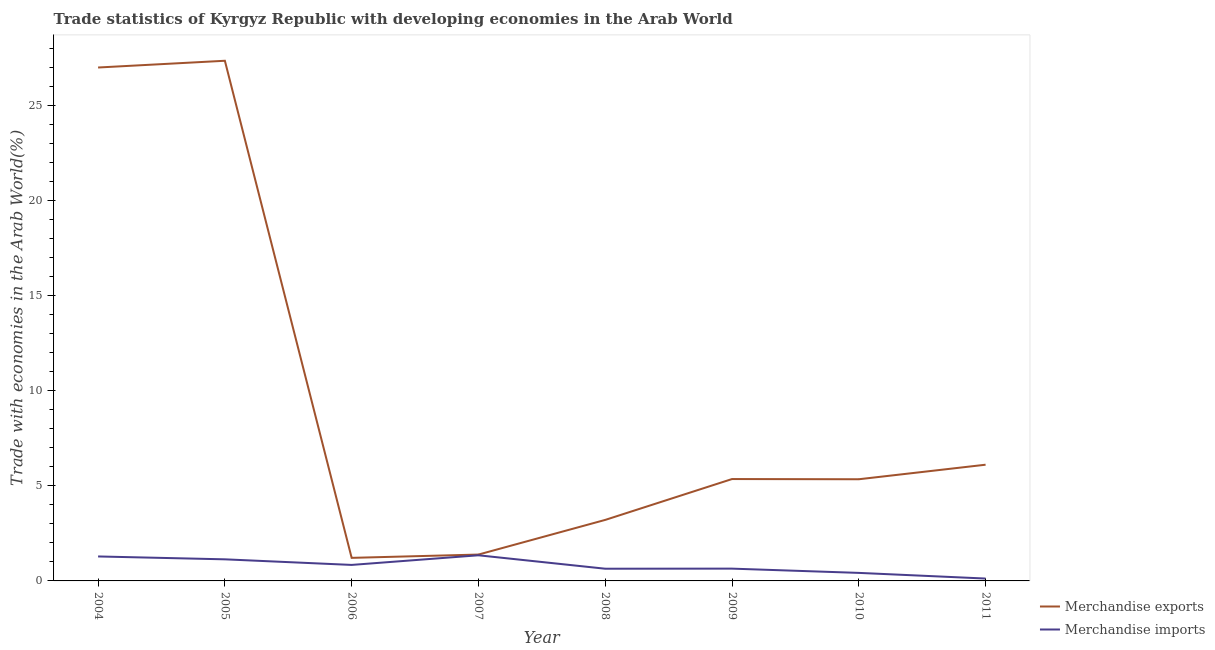How many different coloured lines are there?
Provide a short and direct response. 2. Does the line corresponding to merchandise exports intersect with the line corresponding to merchandise imports?
Make the answer very short. No. Is the number of lines equal to the number of legend labels?
Provide a succinct answer. Yes. What is the merchandise exports in 2005?
Offer a terse response. 27.34. Across all years, what is the maximum merchandise imports?
Make the answer very short. 1.35. Across all years, what is the minimum merchandise exports?
Your response must be concise. 1.21. What is the total merchandise imports in the graph?
Offer a terse response. 6.44. What is the difference between the merchandise imports in 2005 and that in 2011?
Your answer should be compact. 1.01. What is the difference between the merchandise exports in 2011 and the merchandise imports in 2006?
Provide a succinct answer. 5.27. What is the average merchandise imports per year?
Your answer should be compact. 0.81. In the year 2011, what is the difference between the merchandise imports and merchandise exports?
Your answer should be compact. -5.98. What is the ratio of the merchandise exports in 2007 to that in 2008?
Your response must be concise. 0.43. Is the difference between the merchandise exports in 2006 and 2007 greater than the difference between the merchandise imports in 2006 and 2007?
Provide a succinct answer. Yes. What is the difference between the highest and the second highest merchandise exports?
Provide a succinct answer. 0.35. What is the difference between the highest and the lowest merchandise exports?
Offer a terse response. 26.13. In how many years, is the merchandise imports greater than the average merchandise imports taken over all years?
Your answer should be very brief. 4. Does the merchandise imports monotonically increase over the years?
Your answer should be very brief. No. How many lines are there?
Your answer should be very brief. 2. Does the graph contain grids?
Your answer should be very brief. No. What is the title of the graph?
Give a very brief answer. Trade statistics of Kyrgyz Republic with developing economies in the Arab World. What is the label or title of the Y-axis?
Your response must be concise. Trade with economies in the Arab World(%). What is the Trade with economies in the Arab World(%) of Merchandise exports in 2004?
Provide a short and direct response. 26.98. What is the Trade with economies in the Arab World(%) of Merchandise imports in 2004?
Offer a very short reply. 1.29. What is the Trade with economies in the Arab World(%) in Merchandise exports in 2005?
Your answer should be very brief. 27.34. What is the Trade with economies in the Arab World(%) of Merchandise imports in 2005?
Your answer should be compact. 1.13. What is the Trade with economies in the Arab World(%) of Merchandise exports in 2006?
Offer a very short reply. 1.21. What is the Trade with economies in the Arab World(%) in Merchandise imports in 2006?
Offer a very short reply. 0.84. What is the Trade with economies in the Arab World(%) in Merchandise exports in 2007?
Provide a short and direct response. 1.39. What is the Trade with economies in the Arab World(%) of Merchandise imports in 2007?
Provide a short and direct response. 1.35. What is the Trade with economies in the Arab World(%) of Merchandise exports in 2008?
Provide a short and direct response. 3.21. What is the Trade with economies in the Arab World(%) in Merchandise imports in 2008?
Your response must be concise. 0.64. What is the Trade with economies in the Arab World(%) of Merchandise exports in 2009?
Provide a succinct answer. 5.35. What is the Trade with economies in the Arab World(%) in Merchandise imports in 2009?
Your answer should be very brief. 0.65. What is the Trade with economies in the Arab World(%) in Merchandise exports in 2010?
Your answer should be very brief. 5.34. What is the Trade with economies in the Arab World(%) of Merchandise imports in 2010?
Your response must be concise. 0.42. What is the Trade with economies in the Arab World(%) of Merchandise exports in 2011?
Make the answer very short. 6.11. What is the Trade with economies in the Arab World(%) of Merchandise imports in 2011?
Give a very brief answer. 0.12. Across all years, what is the maximum Trade with economies in the Arab World(%) in Merchandise exports?
Offer a terse response. 27.34. Across all years, what is the maximum Trade with economies in the Arab World(%) of Merchandise imports?
Keep it short and to the point. 1.35. Across all years, what is the minimum Trade with economies in the Arab World(%) of Merchandise exports?
Ensure brevity in your answer.  1.21. Across all years, what is the minimum Trade with economies in the Arab World(%) in Merchandise imports?
Give a very brief answer. 0.12. What is the total Trade with economies in the Arab World(%) of Merchandise exports in the graph?
Keep it short and to the point. 76.93. What is the total Trade with economies in the Arab World(%) of Merchandise imports in the graph?
Make the answer very short. 6.44. What is the difference between the Trade with economies in the Arab World(%) in Merchandise exports in 2004 and that in 2005?
Keep it short and to the point. -0.35. What is the difference between the Trade with economies in the Arab World(%) in Merchandise imports in 2004 and that in 2005?
Make the answer very short. 0.15. What is the difference between the Trade with economies in the Arab World(%) in Merchandise exports in 2004 and that in 2006?
Ensure brevity in your answer.  25.77. What is the difference between the Trade with economies in the Arab World(%) in Merchandise imports in 2004 and that in 2006?
Give a very brief answer. 0.44. What is the difference between the Trade with economies in the Arab World(%) of Merchandise exports in 2004 and that in 2007?
Give a very brief answer. 25.6. What is the difference between the Trade with economies in the Arab World(%) of Merchandise imports in 2004 and that in 2007?
Your answer should be very brief. -0.06. What is the difference between the Trade with economies in the Arab World(%) of Merchandise exports in 2004 and that in 2008?
Your answer should be compact. 23.78. What is the difference between the Trade with economies in the Arab World(%) of Merchandise imports in 2004 and that in 2008?
Provide a succinct answer. 0.64. What is the difference between the Trade with economies in the Arab World(%) in Merchandise exports in 2004 and that in 2009?
Provide a short and direct response. 21.63. What is the difference between the Trade with economies in the Arab World(%) in Merchandise imports in 2004 and that in 2009?
Ensure brevity in your answer.  0.64. What is the difference between the Trade with economies in the Arab World(%) in Merchandise exports in 2004 and that in 2010?
Your response must be concise. 21.64. What is the difference between the Trade with economies in the Arab World(%) of Merchandise imports in 2004 and that in 2010?
Give a very brief answer. 0.86. What is the difference between the Trade with economies in the Arab World(%) of Merchandise exports in 2004 and that in 2011?
Provide a short and direct response. 20.88. What is the difference between the Trade with economies in the Arab World(%) of Merchandise imports in 2004 and that in 2011?
Provide a short and direct response. 1.16. What is the difference between the Trade with economies in the Arab World(%) of Merchandise exports in 2005 and that in 2006?
Offer a very short reply. 26.13. What is the difference between the Trade with economies in the Arab World(%) in Merchandise imports in 2005 and that in 2006?
Offer a very short reply. 0.29. What is the difference between the Trade with economies in the Arab World(%) in Merchandise exports in 2005 and that in 2007?
Provide a succinct answer. 25.95. What is the difference between the Trade with economies in the Arab World(%) in Merchandise imports in 2005 and that in 2007?
Your answer should be compact. -0.21. What is the difference between the Trade with economies in the Arab World(%) in Merchandise exports in 2005 and that in 2008?
Keep it short and to the point. 24.13. What is the difference between the Trade with economies in the Arab World(%) of Merchandise imports in 2005 and that in 2008?
Provide a succinct answer. 0.49. What is the difference between the Trade with economies in the Arab World(%) of Merchandise exports in 2005 and that in 2009?
Provide a short and direct response. 21.98. What is the difference between the Trade with economies in the Arab World(%) in Merchandise imports in 2005 and that in 2009?
Offer a very short reply. 0.49. What is the difference between the Trade with economies in the Arab World(%) in Merchandise exports in 2005 and that in 2010?
Keep it short and to the point. 21.99. What is the difference between the Trade with economies in the Arab World(%) in Merchandise imports in 2005 and that in 2010?
Make the answer very short. 0.71. What is the difference between the Trade with economies in the Arab World(%) in Merchandise exports in 2005 and that in 2011?
Give a very brief answer. 21.23. What is the difference between the Trade with economies in the Arab World(%) of Merchandise imports in 2005 and that in 2011?
Keep it short and to the point. 1.01. What is the difference between the Trade with economies in the Arab World(%) in Merchandise exports in 2006 and that in 2007?
Give a very brief answer. -0.17. What is the difference between the Trade with economies in the Arab World(%) in Merchandise imports in 2006 and that in 2007?
Your answer should be compact. -0.51. What is the difference between the Trade with economies in the Arab World(%) of Merchandise exports in 2006 and that in 2008?
Provide a short and direct response. -1.99. What is the difference between the Trade with economies in the Arab World(%) of Merchandise imports in 2006 and that in 2008?
Give a very brief answer. 0.2. What is the difference between the Trade with economies in the Arab World(%) in Merchandise exports in 2006 and that in 2009?
Offer a terse response. -4.14. What is the difference between the Trade with economies in the Arab World(%) in Merchandise imports in 2006 and that in 2009?
Make the answer very short. 0.2. What is the difference between the Trade with economies in the Arab World(%) of Merchandise exports in 2006 and that in 2010?
Provide a short and direct response. -4.13. What is the difference between the Trade with economies in the Arab World(%) in Merchandise imports in 2006 and that in 2010?
Your response must be concise. 0.42. What is the difference between the Trade with economies in the Arab World(%) in Merchandise exports in 2006 and that in 2011?
Keep it short and to the point. -4.9. What is the difference between the Trade with economies in the Arab World(%) of Merchandise imports in 2006 and that in 2011?
Your answer should be compact. 0.72. What is the difference between the Trade with economies in the Arab World(%) of Merchandise exports in 2007 and that in 2008?
Provide a short and direct response. -1.82. What is the difference between the Trade with economies in the Arab World(%) of Merchandise imports in 2007 and that in 2008?
Give a very brief answer. 0.71. What is the difference between the Trade with economies in the Arab World(%) of Merchandise exports in 2007 and that in 2009?
Your answer should be very brief. -3.97. What is the difference between the Trade with economies in the Arab World(%) of Merchandise imports in 2007 and that in 2009?
Keep it short and to the point. 0.7. What is the difference between the Trade with economies in the Arab World(%) of Merchandise exports in 2007 and that in 2010?
Make the answer very short. -3.96. What is the difference between the Trade with economies in the Arab World(%) in Merchandise imports in 2007 and that in 2010?
Ensure brevity in your answer.  0.93. What is the difference between the Trade with economies in the Arab World(%) in Merchandise exports in 2007 and that in 2011?
Ensure brevity in your answer.  -4.72. What is the difference between the Trade with economies in the Arab World(%) in Merchandise imports in 2007 and that in 2011?
Offer a very short reply. 1.22. What is the difference between the Trade with economies in the Arab World(%) of Merchandise exports in 2008 and that in 2009?
Offer a terse response. -2.15. What is the difference between the Trade with economies in the Arab World(%) in Merchandise imports in 2008 and that in 2009?
Provide a short and direct response. -0. What is the difference between the Trade with economies in the Arab World(%) in Merchandise exports in 2008 and that in 2010?
Offer a very short reply. -2.14. What is the difference between the Trade with economies in the Arab World(%) in Merchandise imports in 2008 and that in 2010?
Offer a terse response. 0.22. What is the difference between the Trade with economies in the Arab World(%) in Merchandise exports in 2008 and that in 2011?
Give a very brief answer. -2.9. What is the difference between the Trade with economies in the Arab World(%) of Merchandise imports in 2008 and that in 2011?
Offer a very short reply. 0.52. What is the difference between the Trade with economies in the Arab World(%) in Merchandise exports in 2009 and that in 2010?
Ensure brevity in your answer.  0.01. What is the difference between the Trade with economies in the Arab World(%) in Merchandise imports in 2009 and that in 2010?
Ensure brevity in your answer.  0.22. What is the difference between the Trade with economies in the Arab World(%) of Merchandise exports in 2009 and that in 2011?
Offer a very short reply. -0.75. What is the difference between the Trade with economies in the Arab World(%) in Merchandise imports in 2009 and that in 2011?
Provide a succinct answer. 0.52. What is the difference between the Trade with economies in the Arab World(%) in Merchandise exports in 2010 and that in 2011?
Offer a terse response. -0.76. What is the difference between the Trade with economies in the Arab World(%) in Merchandise imports in 2010 and that in 2011?
Make the answer very short. 0.3. What is the difference between the Trade with economies in the Arab World(%) of Merchandise exports in 2004 and the Trade with economies in the Arab World(%) of Merchandise imports in 2005?
Provide a succinct answer. 25.85. What is the difference between the Trade with economies in the Arab World(%) in Merchandise exports in 2004 and the Trade with economies in the Arab World(%) in Merchandise imports in 2006?
Your answer should be compact. 26.14. What is the difference between the Trade with economies in the Arab World(%) in Merchandise exports in 2004 and the Trade with economies in the Arab World(%) in Merchandise imports in 2007?
Your answer should be compact. 25.64. What is the difference between the Trade with economies in the Arab World(%) of Merchandise exports in 2004 and the Trade with economies in the Arab World(%) of Merchandise imports in 2008?
Offer a very short reply. 26.34. What is the difference between the Trade with economies in the Arab World(%) in Merchandise exports in 2004 and the Trade with economies in the Arab World(%) in Merchandise imports in 2009?
Make the answer very short. 26.34. What is the difference between the Trade with economies in the Arab World(%) of Merchandise exports in 2004 and the Trade with economies in the Arab World(%) of Merchandise imports in 2010?
Ensure brevity in your answer.  26.56. What is the difference between the Trade with economies in the Arab World(%) of Merchandise exports in 2004 and the Trade with economies in the Arab World(%) of Merchandise imports in 2011?
Your response must be concise. 26.86. What is the difference between the Trade with economies in the Arab World(%) in Merchandise exports in 2005 and the Trade with economies in the Arab World(%) in Merchandise imports in 2006?
Ensure brevity in your answer.  26.5. What is the difference between the Trade with economies in the Arab World(%) in Merchandise exports in 2005 and the Trade with economies in the Arab World(%) in Merchandise imports in 2007?
Make the answer very short. 25.99. What is the difference between the Trade with economies in the Arab World(%) of Merchandise exports in 2005 and the Trade with economies in the Arab World(%) of Merchandise imports in 2008?
Keep it short and to the point. 26.7. What is the difference between the Trade with economies in the Arab World(%) in Merchandise exports in 2005 and the Trade with economies in the Arab World(%) in Merchandise imports in 2009?
Your response must be concise. 26.69. What is the difference between the Trade with economies in the Arab World(%) in Merchandise exports in 2005 and the Trade with economies in the Arab World(%) in Merchandise imports in 2010?
Make the answer very short. 26.92. What is the difference between the Trade with economies in the Arab World(%) of Merchandise exports in 2005 and the Trade with economies in the Arab World(%) of Merchandise imports in 2011?
Give a very brief answer. 27.21. What is the difference between the Trade with economies in the Arab World(%) in Merchandise exports in 2006 and the Trade with economies in the Arab World(%) in Merchandise imports in 2007?
Keep it short and to the point. -0.14. What is the difference between the Trade with economies in the Arab World(%) in Merchandise exports in 2006 and the Trade with economies in the Arab World(%) in Merchandise imports in 2008?
Keep it short and to the point. 0.57. What is the difference between the Trade with economies in the Arab World(%) in Merchandise exports in 2006 and the Trade with economies in the Arab World(%) in Merchandise imports in 2009?
Provide a succinct answer. 0.57. What is the difference between the Trade with economies in the Arab World(%) of Merchandise exports in 2006 and the Trade with economies in the Arab World(%) of Merchandise imports in 2010?
Offer a very short reply. 0.79. What is the difference between the Trade with economies in the Arab World(%) in Merchandise exports in 2006 and the Trade with economies in the Arab World(%) in Merchandise imports in 2011?
Give a very brief answer. 1.09. What is the difference between the Trade with economies in the Arab World(%) in Merchandise exports in 2007 and the Trade with economies in the Arab World(%) in Merchandise imports in 2008?
Your answer should be very brief. 0.74. What is the difference between the Trade with economies in the Arab World(%) of Merchandise exports in 2007 and the Trade with economies in the Arab World(%) of Merchandise imports in 2009?
Offer a very short reply. 0.74. What is the difference between the Trade with economies in the Arab World(%) of Merchandise exports in 2007 and the Trade with economies in the Arab World(%) of Merchandise imports in 2010?
Provide a short and direct response. 0.96. What is the difference between the Trade with economies in the Arab World(%) of Merchandise exports in 2007 and the Trade with economies in the Arab World(%) of Merchandise imports in 2011?
Provide a succinct answer. 1.26. What is the difference between the Trade with economies in the Arab World(%) of Merchandise exports in 2008 and the Trade with economies in the Arab World(%) of Merchandise imports in 2009?
Make the answer very short. 2.56. What is the difference between the Trade with economies in the Arab World(%) of Merchandise exports in 2008 and the Trade with economies in the Arab World(%) of Merchandise imports in 2010?
Offer a very short reply. 2.79. What is the difference between the Trade with economies in the Arab World(%) in Merchandise exports in 2008 and the Trade with economies in the Arab World(%) in Merchandise imports in 2011?
Ensure brevity in your answer.  3.08. What is the difference between the Trade with economies in the Arab World(%) of Merchandise exports in 2009 and the Trade with economies in the Arab World(%) of Merchandise imports in 2010?
Your answer should be compact. 4.93. What is the difference between the Trade with economies in the Arab World(%) in Merchandise exports in 2009 and the Trade with economies in the Arab World(%) in Merchandise imports in 2011?
Make the answer very short. 5.23. What is the difference between the Trade with economies in the Arab World(%) of Merchandise exports in 2010 and the Trade with economies in the Arab World(%) of Merchandise imports in 2011?
Offer a very short reply. 5.22. What is the average Trade with economies in the Arab World(%) of Merchandise exports per year?
Your answer should be compact. 9.62. What is the average Trade with economies in the Arab World(%) of Merchandise imports per year?
Your response must be concise. 0.81. In the year 2004, what is the difference between the Trade with economies in the Arab World(%) of Merchandise exports and Trade with economies in the Arab World(%) of Merchandise imports?
Give a very brief answer. 25.7. In the year 2005, what is the difference between the Trade with economies in the Arab World(%) in Merchandise exports and Trade with economies in the Arab World(%) in Merchandise imports?
Your response must be concise. 26.2. In the year 2006, what is the difference between the Trade with economies in the Arab World(%) of Merchandise exports and Trade with economies in the Arab World(%) of Merchandise imports?
Offer a very short reply. 0.37. In the year 2007, what is the difference between the Trade with economies in the Arab World(%) in Merchandise exports and Trade with economies in the Arab World(%) in Merchandise imports?
Provide a succinct answer. 0.04. In the year 2008, what is the difference between the Trade with economies in the Arab World(%) of Merchandise exports and Trade with economies in the Arab World(%) of Merchandise imports?
Offer a terse response. 2.57. In the year 2009, what is the difference between the Trade with economies in the Arab World(%) in Merchandise exports and Trade with economies in the Arab World(%) in Merchandise imports?
Offer a terse response. 4.71. In the year 2010, what is the difference between the Trade with economies in the Arab World(%) in Merchandise exports and Trade with economies in the Arab World(%) in Merchandise imports?
Offer a terse response. 4.92. In the year 2011, what is the difference between the Trade with economies in the Arab World(%) in Merchandise exports and Trade with economies in the Arab World(%) in Merchandise imports?
Give a very brief answer. 5.98. What is the ratio of the Trade with economies in the Arab World(%) in Merchandise exports in 2004 to that in 2005?
Provide a short and direct response. 0.99. What is the ratio of the Trade with economies in the Arab World(%) in Merchandise imports in 2004 to that in 2005?
Give a very brief answer. 1.13. What is the ratio of the Trade with economies in the Arab World(%) of Merchandise exports in 2004 to that in 2006?
Provide a short and direct response. 22.26. What is the ratio of the Trade with economies in the Arab World(%) of Merchandise imports in 2004 to that in 2006?
Give a very brief answer. 1.53. What is the ratio of the Trade with economies in the Arab World(%) of Merchandise exports in 2004 to that in 2007?
Offer a terse response. 19.47. What is the ratio of the Trade with economies in the Arab World(%) of Merchandise imports in 2004 to that in 2007?
Make the answer very short. 0.95. What is the ratio of the Trade with economies in the Arab World(%) of Merchandise exports in 2004 to that in 2008?
Your answer should be compact. 8.41. What is the ratio of the Trade with economies in the Arab World(%) of Merchandise imports in 2004 to that in 2008?
Offer a terse response. 2. What is the ratio of the Trade with economies in the Arab World(%) in Merchandise exports in 2004 to that in 2009?
Your answer should be compact. 5.04. What is the ratio of the Trade with economies in the Arab World(%) in Merchandise imports in 2004 to that in 2009?
Offer a terse response. 1.99. What is the ratio of the Trade with economies in the Arab World(%) of Merchandise exports in 2004 to that in 2010?
Make the answer very short. 5.05. What is the ratio of the Trade with economies in the Arab World(%) in Merchandise imports in 2004 to that in 2010?
Make the answer very short. 3.05. What is the ratio of the Trade with economies in the Arab World(%) of Merchandise exports in 2004 to that in 2011?
Ensure brevity in your answer.  4.42. What is the ratio of the Trade with economies in the Arab World(%) of Merchandise imports in 2004 to that in 2011?
Your answer should be compact. 10.29. What is the ratio of the Trade with economies in the Arab World(%) in Merchandise exports in 2005 to that in 2006?
Give a very brief answer. 22.55. What is the ratio of the Trade with economies in the Arab World(%) of Merchandise imports in 2005 to that in 2006?
Your answer should be very brief. 1.35. What is the ratio of the Trade with economies in the Arab World(%) in Merchandise exports in 2005 to that in 2007?
Offer a very short reply. 19.73. What is the ratio of the Trade with economies in the Arab World(%) of Merchandise imports in 2005 to that in 2007?
Make the answer very short. 0.84. What is the ratio of the Trade with economies in the Arab World(%) in Merchandise exports in 2005 to that in 2008?
Offer a very short reply. 8.52. What is the ratio of the Trade with economies in the Arab World(%) in Merchandise imports in 2005 to that in 2008?
Provide a short and direct response. 1.77. What is the ratio of the Trade with economies in the Arab World(%) of Merchandise exports in 2005 to that in 2009?
Provide a short and direct response. 5.11. What is the ratio of the Trade with economies in the Arab World(%) of Merchandise imports in 2005 to that in 2009?
Keep it short and to the point. 1.76. What is the ratio of the Trade with economies in the Arab World(%) in Merchandise exports in 2005 to that in 2010?
Offer a very short reply. 5.12. What is the ratio of the Trade with economies in the Arab World(%) in Merchandise imports in 2005 to that in 2010?
Make the answer very short. 2.69. What is the ratio of the Trade with economies in the Arab World(%) in Merchandise exports in 2005 to that in 2011?
Your answer should be compact. 4.48. What is the ratio of the Trade with economies in the Arab World(%) in Merchandise imports in 2005 to that in 2011?
Keep it short and to the point. 9.09. What is the ratio of the Trade with economies in the Arab World(%) of Merchandise exports in 2006 to that in 2007?
Your answer should be very brief. 0.87. What is the ratio of the Trade with economies in the Arab World(%) of Merchandise imports in 2006 to that in 2007?
Offer a very short reply. 0.62. What is the ratio of the Trade with economies in the Arab World(%) of Merchandise exports in 2006 to that in 2008?
Keep it short and to the point. 0.38. What is the ratio of the Trade with economies in the Arab World(%) in Merchandise imports in 2006 to that in 2008?
Ensure brevity in your answer.  1.31. What is the ratio of the Trade with economies in the Arab World(%) of Merchandise exports in 2006 to that in 2009?
Make the answer very short. 0.23. What is the ratio of the Trade with economies in the Arab World(%) of Merchandise imports in 2006 to that in 2009?
Offer a terse response. 1.3. What is the ratio of the Trade with economies in the Arab World(%) of Merchandise exports in 2006 to that in 2010?
Your response must be concise. 0.23. What is the ratio of the Trade with economies in the Arab World(%) of Merchandise imports in 2006 to that in 2010?
Offer a terse response. 1.99. What is the ratio of the Trade with economies in the Arab World(%) in Merchandise exports in 2006 to that in 2011?
Ensure brevity in your answer.  0.2. What is the ratio of the Trade with economies in the Arab World(%) in Merchandise imports in 2006 to that in 2011?
Offer a very short reply. 6.73. What is the ratio of the Trade with economies in the Arab World(%) of Merchandise exports in 2007 to that in 2008?
Provide a succinct answer. 0.43. What is the ratio of the Trade with economies in the Arab World(%) in Merchandise imports in 2007 to that in 2008?
Make the answer very short. 2.1. What is the ratio of the Trade with economies in the Arab World(%) of Merchandise exports in 2007 to that in 2009?
Give a very brief answer. 0.26. What is the ratio of the Trade with economies in the Arab World(%) of Merchandise imports in 2007 to that in 2009?
Provide a short and direct response. 2.09. What is the ratio of the Trade with economies in the Arab World(%) in Merchandise exports in 2007 to that in 2010?
Offer a terse response. 0.26. What is the ratio of the Trade with economies in the Arab World(%) in Merchandise imports in 2007 to that in 2010?
Provide a succinct answer. 3.19. What is the ratio of the Trade with economies in the Arab World(%) of Merchandise exports in 2007 to that in 2011?
Offer a very short reply. 0.23. What is the ratio of the Trade with economies in the Arab World(%) in Merchandise imports in 2007 to that in 2011?
Give a very brief answer. 10.79. What is the ratio of the Trade with economies in the Arab World(%) in Merchandise exports in 2008 to that in 2009?
Give a very brief answer. 0.6. What is the ratio of the Trade with economies in the Arab World(%) of Merchandise exports in 2008 to that in 2010?
Ensure brevity in your answer.  0.6. What is the ratio of the Trade with economies in the Arab World(%) in Merchandise imports in 2008 to that in 2010?
Ensure brevity in your answer.  1.52. What is the ratio of the Trade with economies in the Arab World(%) of Merchandise exports in 2008 to that in 2011?
Provide a succinct answer. 0.53. What is the ratio of the Trade with economies in the Arab World(%) of Merchandise imports in 2008 to that in 2011?
Ensure brevity in your answer.  5.13. What is the ratio of the Trade with economies in the Arab World(%) in Merchandise imports in 2009 to that in 2010?
Ensure brevity in your answer.  1.53. What is the ratio of the Trade with economies in the Arab World(%) of Merchandise exports in 2009 to that in 2011?
Make the answer very short. 0.88. What is the ratio of the Trade with economies in the Arab World(%) in Merchandise imports in 2009 to that in 2011?
Offer a terse response. 5.17. What is the ratio of the Trade with economies in the Arab World(%) of Merchandise exports in 2010 to that in 2011?
Give a very brief answer. 0.87. What is the ratio of the Trade with economies in the Arab World(%) in Merchandise imports in 2010 to that in 2011?
Ensure brevity in your answer.  3.38. What is the difference between the highest and the second highest Trade with economies in the Arab World(%) in Merchandise exports?
Your answer should be compact. 0.35. What is the difference between the highest and the second highest Trade with economies in the Arab World(%) in Merchandise imports?
Offer a terse response. 0.06. What is the difference between the highest and the lowest Trade with economies in the Arab World(%) of Merchandise exports?
Provide a short and direct response. 26.13. What is the difference between the highest and the lowest Trade with economies in the Arab World(%) in Merchandise imports?
Keep it short and to the point. 1.22. 